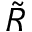Convert formula to latex. <formula><loc_0><loc_0><loc_500><loc_500>\tilde { R }</formula> 